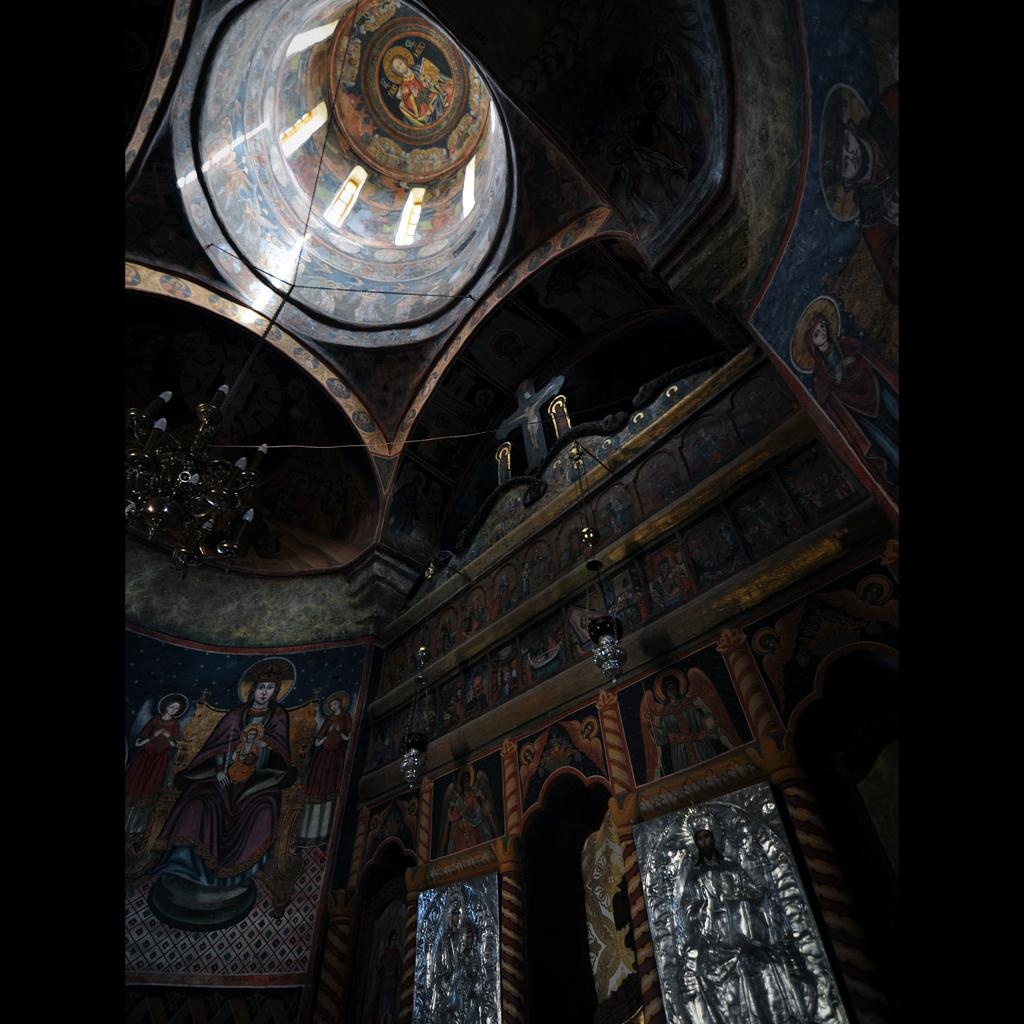What type of location is depicted in the image? The image shows the inside of a building. What decorative elements can be seen on the walls? There are paintings on the walls. What other types of art are visible in the image? There are sculptures visible in the image. What type of government is depicted in the sculpture in the image? There is no government depicted in the sculpture in the image; it is a sculpture and not a representation of a political system. 